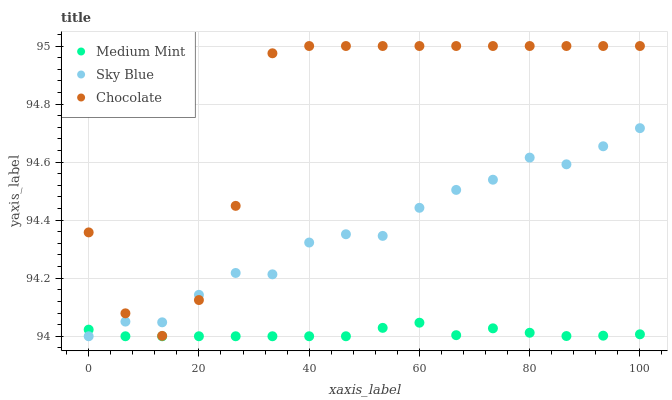Does Medium Mint have the minimum area under the curve?
Answer yes or no. Yes. Does Chocolate have the maximum area under the curve?
Answer yes or no. Yes. Does Sky Blue have the minimum area under the curve?
Answer yes or no. No. Does Sky Blue have the maximum area under the curve?
Answer yes or no. No. Is Medium Mint the smoothest?
Answer yes or no. Yes. Is Chocolate the roughest?
Answer yes or no. Yes. Is Sky Blue the smoothest?
Answer yes or no. No. Is Sky Blue the roughest?
Answer yes or no. No. Does Medium Mint have the lowest value?
Answer yes or no. Yes. Does Chocolate have the lowest value?
Answer yes or no. No. Does Chocolate have the highest value?
Answer yes or no. Yes. Does Sky Blue have the highest value?
Answer yes or no. No. Is Medium Mint less than Chocolate?
Answer yes or no. Yes. Is Chocolate greater than Medium Mint?
Answer yes or no. Yes. Does Medium Mint intersect Sky Blue?
Answer yes or no. Yes. Is Medium Mint less than Sky Blue?
Answer yes or no. No. Is Medium Mint greater than Sky Blue?
Answer yes or no. No. Does Medium Mint intersect Chocolate?
Answer yes or no. No. 